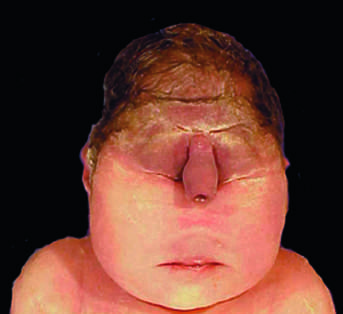what is associated with severe internal anomalies such as maldevelopment of the brain and cardiac defects in almost all cases?
Answer the question using a single word or phrase. This degree of external dysmorphogenesis 